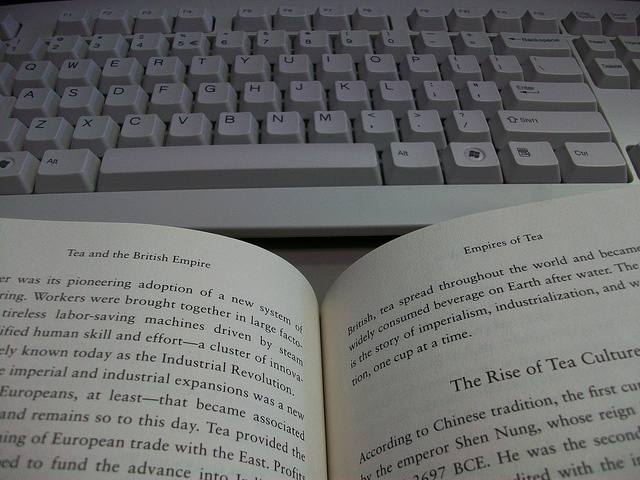Describe the objects in this image and their specific colors. I can see book in black, darkgray, and gray tones and keyboard in black, gray, and purple tones in this image. 